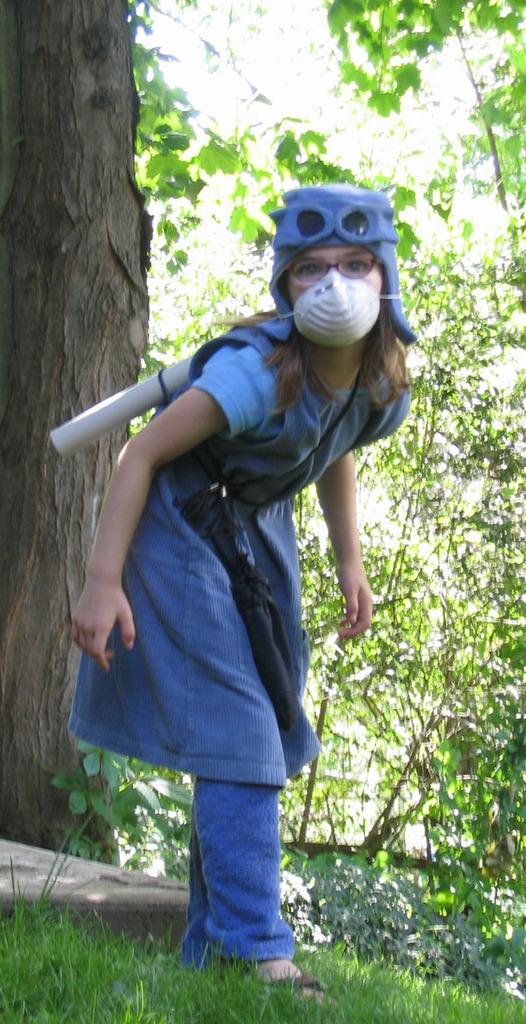Who is the main subject in the image? There is a girl in the image. What is the girl doing in the image? The girl is standing. What is the girl wearing in the image? The girl is wearing a blue dress and a mask. What can be seen in the background of the image? There is a tree in the image, and the land is full of grass. What is a characteristic of the tree in the image? The tree has bark. What type of comb is the girl using to gather her ideas in the image? There is no comb or mention of gathering ideas in the image; the girl is wearing a mask and standing near a tree. 